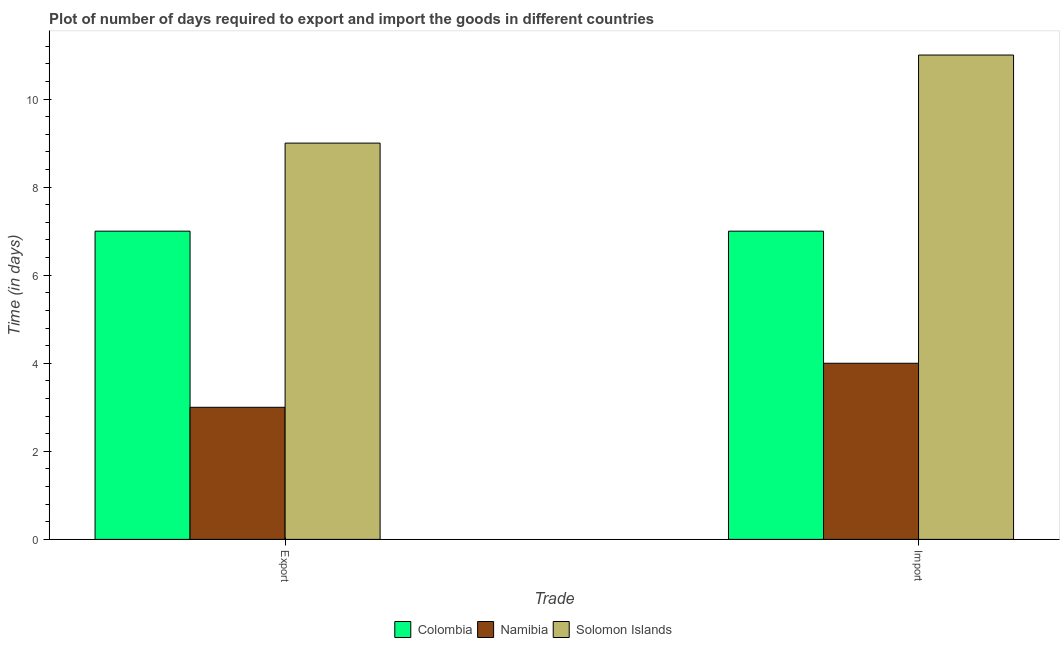How many groups of bars are there?
Offer a terse response. 2. Are the number of bars on each tick of the X-axis equal?
Your answer should be compact. Yes. How many bars are there on the 2nd tick from the left?
Keep it short and to the point. 3. How many bars are there on the 2nd tick from the right?
Provide a succinct answer. 3. What is the label of the 1st group of bars from the left?
Your answer should be compact. Export. What is the time required to import in Namibia?
Offer a terse response. 4. Across all countries, what is the maximum time required to export?
Ensure brevity in your answer.  9. Across all countries, what is the minimum time required to import?
Offer a terse response. 4. In which country was the time required to export maximum?
Your answer should be very brief. Solomon Islands. In which country was the time required to export minimum?
Make the answer very short. Namibia. What is the total time required to export in the graph?
Make the answer very short. 19. What is the difference between the time required to export in Colombia and that in Solomon Islands?
Make the answer very short. -2. What is the difference between the time required to export in Namibia and the time required to import in Solomon Islands?
Give a very brief answer. -8. What is the average time required to import per country?
Give a very brief answer. 7.33. What is the difference between the time required to import and time required to export in Namibia?
Keep it short and to the point. 1. In how many countries, is the time required to export greater than 4 days?
Your answer should be very brief. 2. What is the ratio of the time required to export in Colombia to that in Namibia?
Your answer should be compact. 2.33. Is the time required to import in Colombia less than that in Namibia?
Your response must be concise. No. In how many countries, is the time required to import greater than the average time required to import taken over all countries?
Provide a succinct answer. 1. What does the 1st bar from the left in Export represents?
Make the answer very short. Colombia. What does the 2nd bar from the right in Import represents?
Offer a very short reply. Namibia. Are the values on the major ticks of Y-axis written in scientific E-notation?
Your response must be concise. No. Where does the legend appear in the graph?
Your response must be concise. Bottom center. How are the legend labels stacked?
Keep it short and to the point. Horizontal. What is the title of the graph?
Keep it short and to the point. Plot of number of days required to export and import the goods in different countries. Does "Grenada" appear as one of the legend labels in the graph?
Offer a terse response. No. What is the label or title of the X-axis?
Provide a succinct answer. Trade. What is the label or title of the Y-axis?
Give a very brief answer. Time (in days). What is the Time (in days) in Namibia in Export?
Give a very brief answer. 3. What is the Time (in days) in Solomon Islands in Export?
Make the answer very short. 9. What is the Time (in days) of Colombia in Import?
Ensure brevity in your answer.  7. Across all Trade, what is the maximum Time (in days) of Namibia?
Your response must be concise. 4. Across all Trade, what is the maximum Time (in days) in Solomon Islands?
Provide a short and direct response. 11. Across all Trade, what is the minimum Time (in days) of Colombia?
Offer a very short reply. 7. Across all Trade, what is the minimum Time (in days) of Solomon Islands?
Provide a succinct answer. 9. What is the total Time (in days) in Solomon Islands in the graph?
Make the answer very short. 20. What is the difference between the Time (in days) of Colombia in Export and the Time (in days) of Namibia in Import?
Your response must be concise. 3. What is the difference between the Time (in days) in Colombia in Export and the Time (in days) in Solomon Islands in Import?
Your answer should be compact. -4. What is the difference between the Time (in days) in Namibia in Export and the Time (in days) in Solomon Islands in Import?
Your answer should be compact. -8. What is the average Time (in days) of Colombia per Trade?
Your answer should be compact. 7. What is the average Time (in days) in Namibia per Trade?
Make the answer very short. 3.5. What is the average Time (in days) in Solomon Islands per Trade?
Your response must be concise. 10. What is the difference between the Time (in days) of Colombia and Time (in days) of Namibia in Import?
Your answer should be compact. 3. What is the difference between the Time (in days) of Colombia and Time (in days) of Solomon Islands in Import?
Your answer should be compact. -4. What is the ratio of the Time (in days) of Colombia in Export to that in Import?
Your answer should be very brief. 1. What is the ratio of the Time (in days) of Namibia in Export to that in Import?
Offer a very short reply. 0.75. What is the ratio of the Time (in days) of Solomon Islands in Export to that in Import?
Provide a succinct answer. 0.82. What is the difference between the highest and the second highest Time (in days) of Colombia?
Your answer should be very brief. 0. What is the difference between the highest and the lowest Time (in days) of Colombia?
Offer a very short reply. 0. What is the difference between the highest and the lowest Time (in days) of Namibia?
Your answer should be compact. 1. What is the difference between the highest and the lowest Time (in days) in Solomon Islands?
Give a very brief answer. 2. 